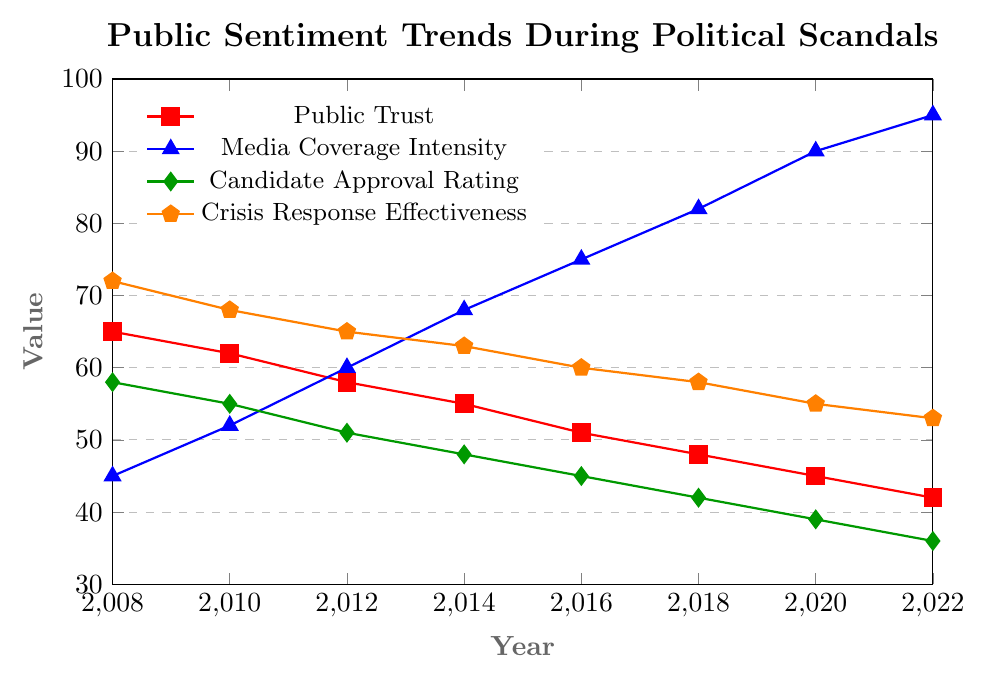What was the value of Public Trust in 2012? Locate the "Public Trust" series in the figure. Check the value on the y-axis corresponding to the year 2012.
Answer: 58 Which parameter exhibited the greatest increase from 2008 to 2022? Analyze all trends from 2008 to 2022. Calculate the difference for each parameter across these years: Public Trust (65 to 42, a decrease), Media Coverage Intensity (45 to 95, an increase of 50), Candidate Approval Rating (58 to 36, a decrease), Crisis Response Effectiveness (72 to 53, a decrease).
Answer: Media Coverage Intensity What was the difference in Candidate Approval Rating between 2014 and 2018? Locate the "Candidate Approval Rating" series and read the values for the years 2014 and 2018. Subtract the value in 2018 from that in 2014: 48 - 42.
Answer: 6 How did the Media Coverage Intensity change between 2010 and 2016? Check the "Media Coverage Intensity" series and find the values for the years 2010 and 2016. Subtract the 2010 value from the 2016 value: 75 - 52.
Answer: 23 Which parameter showed the least change over the period from 2008 to 2022? Analyze each parameter's initial and final values from 2008 to 2022. Calculate the absolute differences: Public Trust (65 - 42 = 23), Media Coverage Intensity (95 - 45 = 50), Candidate Approval Rating (58 - 36 = 22), Crisis Response Effectiveness (72 - 53 = 19).
Answer: Crisis Response Effectiveness On the whole, how did the Candidate Approval Rating and Public Trust vary together over the years? Observe the trends for both "Candidate Approval Rating" and "Public Trust." Both parameters show a decreasing trend. Calculate the declines: Public Trust from 65 to 42, Candidate Approval Rating from 58 to 36.
Answer: Both decreased By how much did Crisis Response Effectiveness drop from 2008 to 2022? Find the "Crisis Response Effectiveness" values for the years 2008 and 2022. Subtract the 2022 value from the 2008 value: 72 - 53.
Answer: 19 